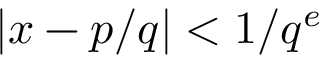<formula> <loc_0><loc_0><loc_500><loc_500>| x - p / q | < 1 / q ^ { e }</formula> 